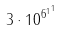<formula> <loc_0><loc_0><loc_500><loc_500>3 \cdot 1 0 ^ { { 6 ^ { 1 } } ^ { 1 } }</formula> 